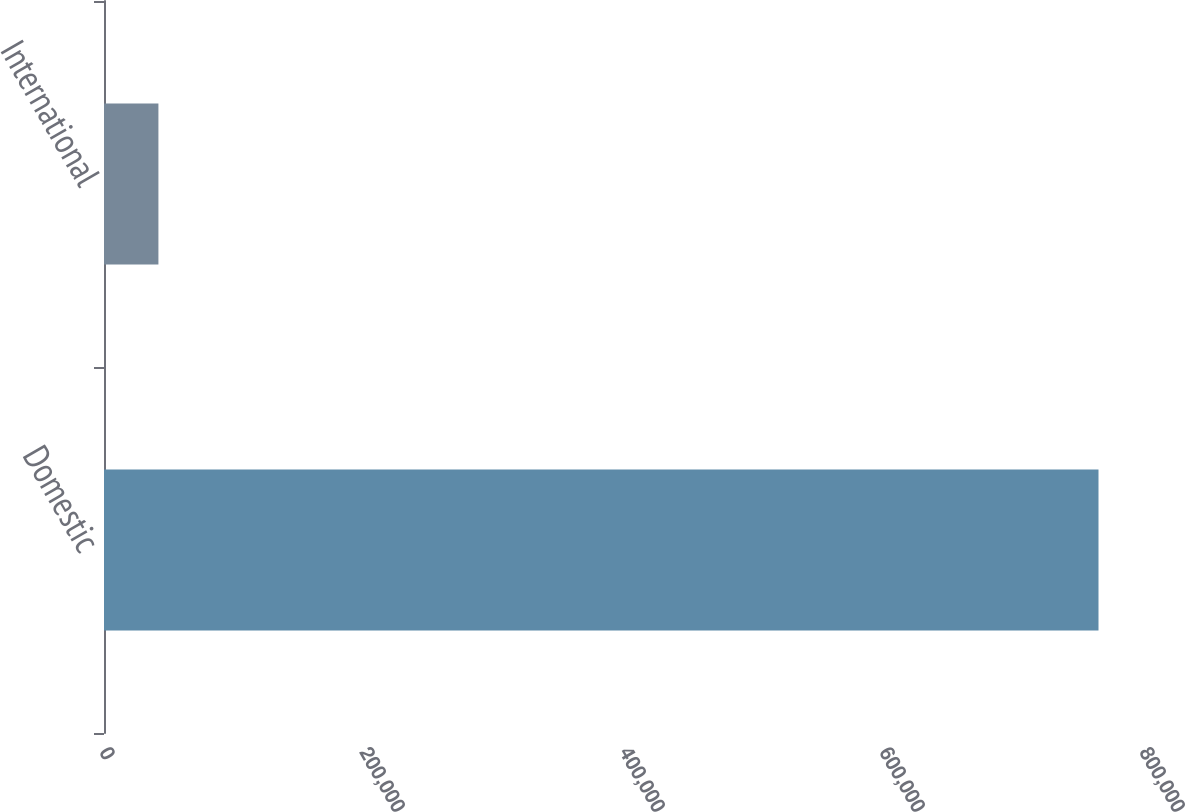Convert chart. <chart><loc_0><loc_0><loc_500><loc_500><bar_chart><fcel>Domestic<fcel>International<nl><fcel>764998<fcel>41862<nl></chart> 